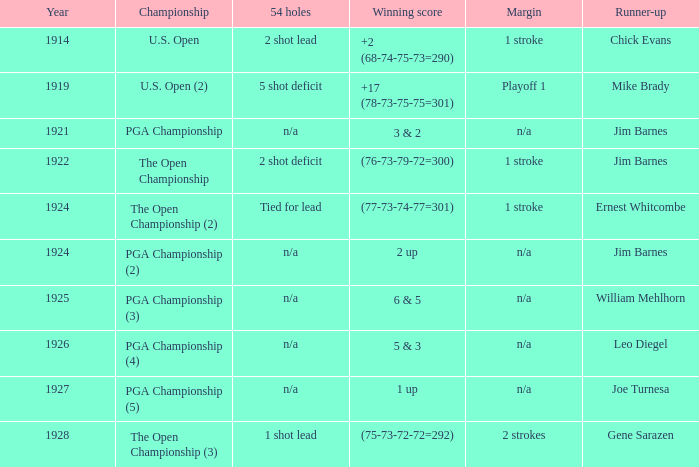WHAT YEAR WAS IT WHEN THE SCORE WAS 3 & 2? 1921.0. 